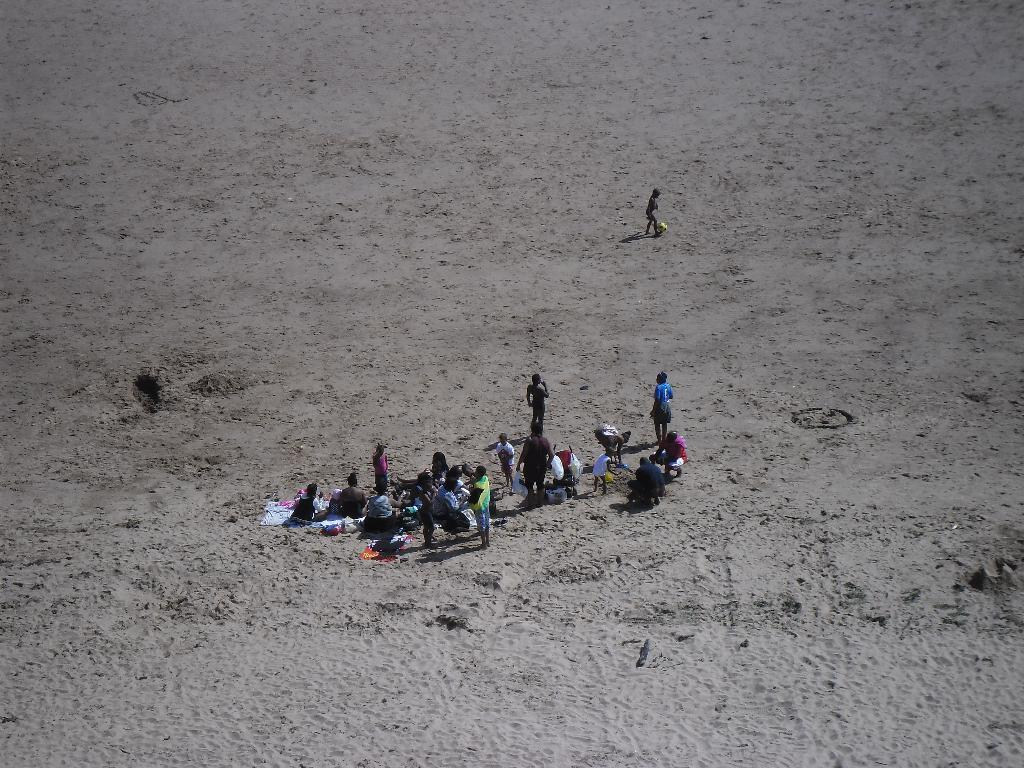What is the main subject of the image? The main subject of the image is a group of people. Where are the people located in the image? The people are on the sand in the image. What are some of the people doing in the image? Some people are sitting, and some are standing. Can you describe any objects or things visible in the image? There are objects and things visible in the image, but the specifics are not mentioned in the provided facts. What type of tiger can be seen in the image? There is no tiger present in the image; it features a group of people on the sand. 